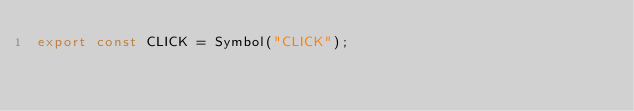<code> <loc_0><loc_0><loc_500><loc_500><_JavaScript_>export const CLICK = Symbol("CLICK");</code> 